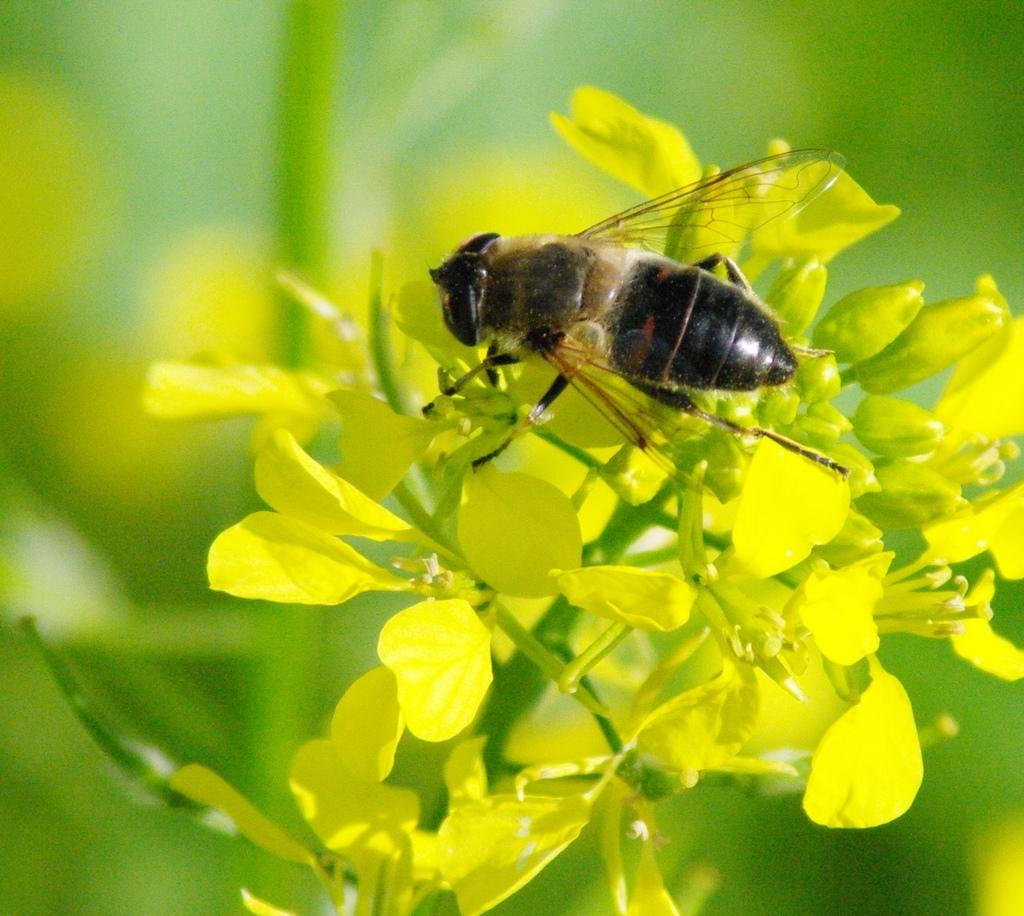What is the main subject of the image? There is a bee in the image. What is the bee standing on? The bee is standing on a yellow flower plant. Can you describe the background of the image? The background of the image is blurry. What type of loss is the bee experiencing in the image? There is no indication of any loss in the image; the bee is standing on a yellow flower plant. How does the bee smash the flower in the image? The bee is not smashing the flower in the image; it is standing on it. 